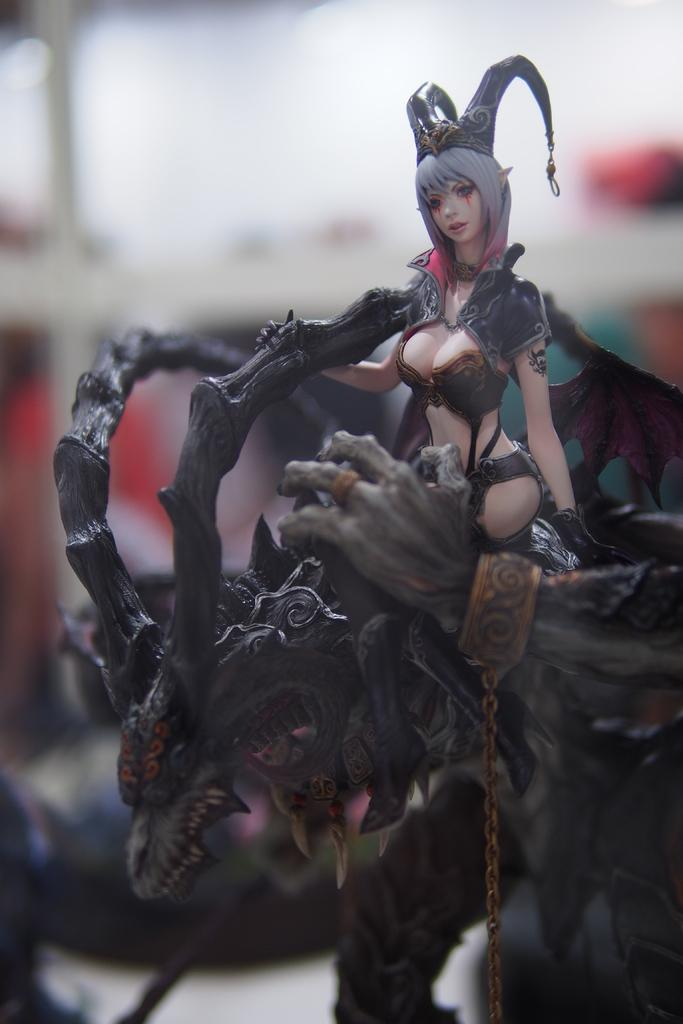What object is present in the image that is not a living creature? There is a toy in the image. What is the toy sitting on? The toy is sitting on an animal. What color is the animal in the image? The animal is black in color. How many books are stacked on the glass table in the image? There is no glass table or books present in the image. 